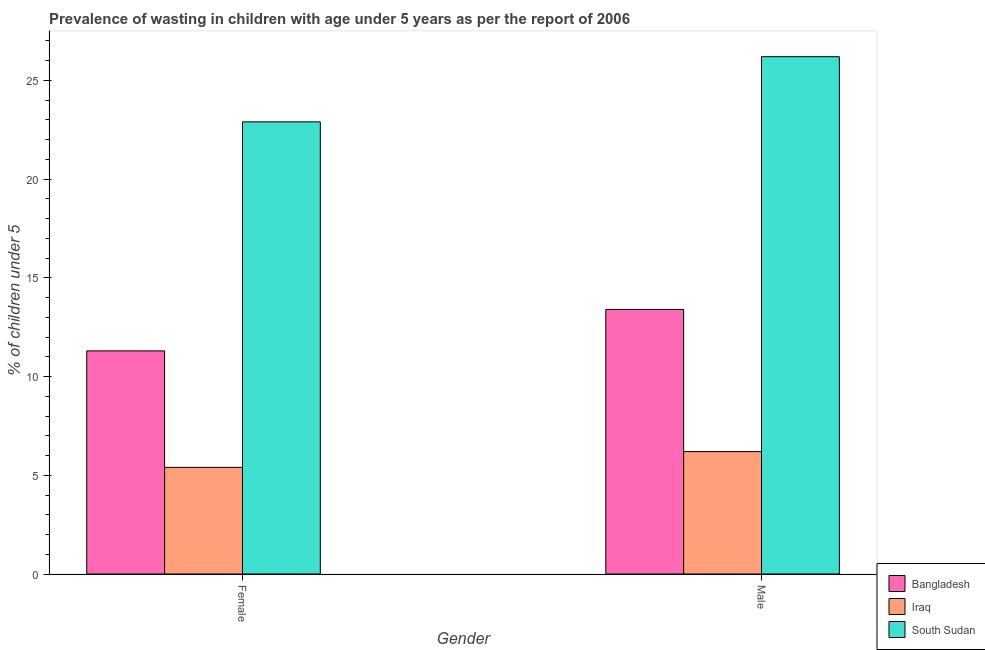How many groups of bars are there?
Provide a succinct answer. 2. Are the number of bars per tick equal to the number of legend labels?
Keep it short and to the point. Yes. Are the number of bars on each tick of the X-axis equal?
Your answer should be compact. Yes. What is the percentage of undernourished male children in Iraq?
Your response must be concise. 6.2. Across all countries, what is the maximum percentage of undernourished female children?
Keep it short and to the point. 22.9. Across all countries, what is the minimum percentage of undernourished male children?
Offer a terse response. 6.2. In which country was the percentage of undernourished male children maximum?
Make the answer very short. South Sudan. In which country was the percentage of undernourished female children minimum?
Make the answer very short. Iraq. What is the total percentage of undernourished male children in the graph?
Provide a succinct answer. 45.8. What is the difference between the percentage of undernourished male children in South Sudan and that in Bangladesh?
Give a very brief answer. 12.8. What is the difference between the percentage of undernourished male children in Iraq and the percentage of undernourished female children in Bangladesh?
Give a very brief answer. -5.1. What is the average percentage of undernourished male children per country?
Ensure brevity in your answer.  15.27. What is the difference between the percentage of undernourished female children and percentage of undernourished male children in Bangladesh?
Keep it short and to the point. -2.1. What is the ratio of the percentage of undernourished female children in Bangladesh to that in South Sudan?
Your answer should be compact. 0.49. In how many countries, is the percentage of undernourished male children greater than the average percentage of undernourished male children taken over all countries?
Keep it short and to the point. 1. What does the 1st bar from the left in Female represents?
Ensure brevity in your answer.  Bangladesh. What does the 1st bar from the right in Male represents?
Keep it short and to the point. South Sudan. How many bars are there?
Make the answer very short. 6. How many countries are there in the graph?
Give a very brief answer. 3. What is the difference between two consecutive major ticks on the Y-axis?
Give a very brief answer. 5. Does the graph contain any zero values?
Make the answer very short. No. Where does the legend appear in the graph?
Offer a very short reply. Bottom right. How many legend labels are there?
Give a very brief answer. 3. How are the legend labels stacked?
Your answer should be compact. Vertical. What is the title of the graph?
Your answer should be compact. Prevalence of wasting in children with age under 5 years as per the report of 2006. What is the label or title of the Y-axis?
Your answer should be very brief.  % of children under 5. What is the  % of children under 5 in Bangladesh in Female?
Offer a very short reply. 11.3. What is the  % of children under 5 in Iraq in Female?
Ensure brevity in your answer.  5.4. What is the  % of children under 5 in South Sudan in Female?
Make the answer very short. 22.9. What is the  % of children under 5 of Bangladesh in Male?
Your answer should be compact. 13.4. What is the  % of children under 5 of Iraq in Male?
Make the answer very short. 6.2. What is the  % of children under 5 of South Sudan in Male?
Offer a terse response. 26.2. Across all Gender, what is the maximum  % of children under 5 in Bangladesh?
Your response must be concise. 13.4. Across all Gender, what is the maximum  % of children under 5 of Iraq?
Keep it short and to the point. 6.2. Across all Gender, what is the maximum  % of children under 5 in South Sudan?
Give a very brief answer. 26.2. Across all Gender, what is the minimum  % of children under 5 of Bangladesh?
Your response must be concise. 11.3. Across all Gender, what is the minimum  % of children under 5 of Iraq?
Offer a terse response. 5.4. Across all Gender, what is the minimum  % of children under 5 in South Sudan?
Keep it short and to the point. 22.9. What is the total  % of children under 5 in Bangladesh in the graph?
Give a very brief answer. 24.7. What is the total  % of children under 5 in Iraq in the graph?
Your response must be concise. 11.6. What is the total  % of children under 5 of South Sudan in the graph?
Offer a very short reply. 49.1. What is the difference between the  % of children under 5 in Bangladesh in Female and the  % of children under 5 in Iraq in Male?
Your response must be concise. 5.1. What is the difference between the  % of children under 5 of Bangladesh in Female and the  % of children under 5 of South Sudan in Male?
Your answer should be compact. -14.9. What is the difference between the  % of children under 5 in Iraq in Female and the  % of children under 5 in South Sudan in Male?
Your answer should be compact. -20.8. What is the average  % of children under 5 of Bangladesh per Gender?
Your response must be concise. 12.35. What is the average  % of children under 5 of South Sudan per Gender?
Provide a short and direct response. 24.55. What is the difference between the  % of children under 5 in Iraq and  % of children under 5 in South Sudan in Female?
Provide a succinct answer. -17.5. What is the difference between the  % of children under 5 of Bangladesh and  % of children under 5 of Iraq in Male?
Offer a terse response. 7.2. What is the difference between the  % of children under 5 of Bangladesh and  % of children under 5 of South Sudan in Male?
Offer a terse response. -12.8. What is the difference between the  % of children under 5 of Iraq and  % of children under 5 of South Sudan in Male?
Give a very brief answer. -20. What is the ratio of the  % of children under 5 in Bangladesh in Female to that in Male?
Provide a short and direct response. 0.84. What is the ratio of the  % of children under 5 in Iraq in Female to that in Male?
Provide a succinct answer. 0.87. What is the ratio of the  % of children under 5 of South Sudan in Female to that in Male?
Keep it short and to the point. 0.87. What is the difference between the highest and the second highest  % of children under 5 of Bangladesh?
Ensure brevity in your answer.  2.1. What is the difference between the highest and the second highest  % of children under 5 of Iraq?
Offer a very short reply. 0.8. What is the difference between the highest and the second highest  % of children under 5 in South Sudan?
Your response must be concise. 3.3. What is the difference between the highest and the lowest  % of children under 5 in Bangladesh?
Your answer should be very brief. 2.1. What is the difference between the highest and the lowest  % of children under 5 of Iraq?
Make the answer very short. 0.8. 